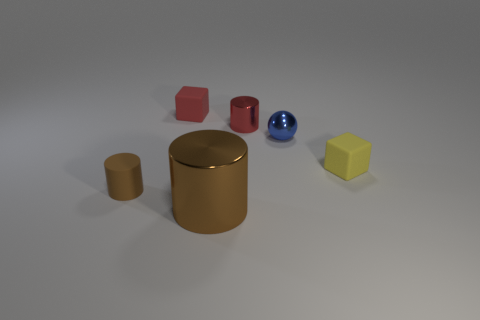Are there any other things that have the same size as the brown shiny object?
Your answer should be very brief. No. There is a red thing on the right side of the big brown shiny thing; what shape is it?
Provide a succinct answer. Cylinder. Are there any objects that are to the left of the tiny block that is right of the block to the left of the red metal cylinder?
Keep it short and to the point. Yes. Is there any other thing that is the same shape as the large metal object?
Offer a terse response. Yes. Are any tiny brown rubber things visible?
Your answer should be compact. Yes. Is the material of the tiny red thing that is to the left of the small red shiny thing the same as the cylinder left of the big brown metallic thing?
Give a very brief answer. Yes. What size is the rubber object to the right of the rubber block behind the tiny blue shiny sphere that is to the right of the large object?
Your response must be concise. Small. How many tiny yellow things are the same material as the tiny blue ball?
Give a very brief answer. 0. Is the number of red blocks less than the number of large gray rubber spheres?
Your answer should be very brief. No. There is a red object that is the same shape as the brown rubber thing; what size is it?
Your response must be concise. Small. 